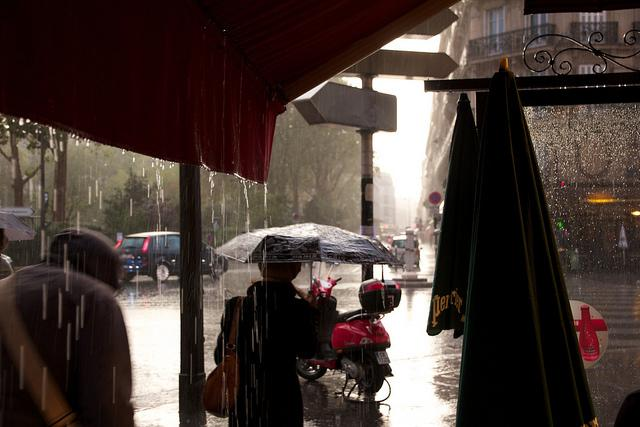Where does this water come from? sky 